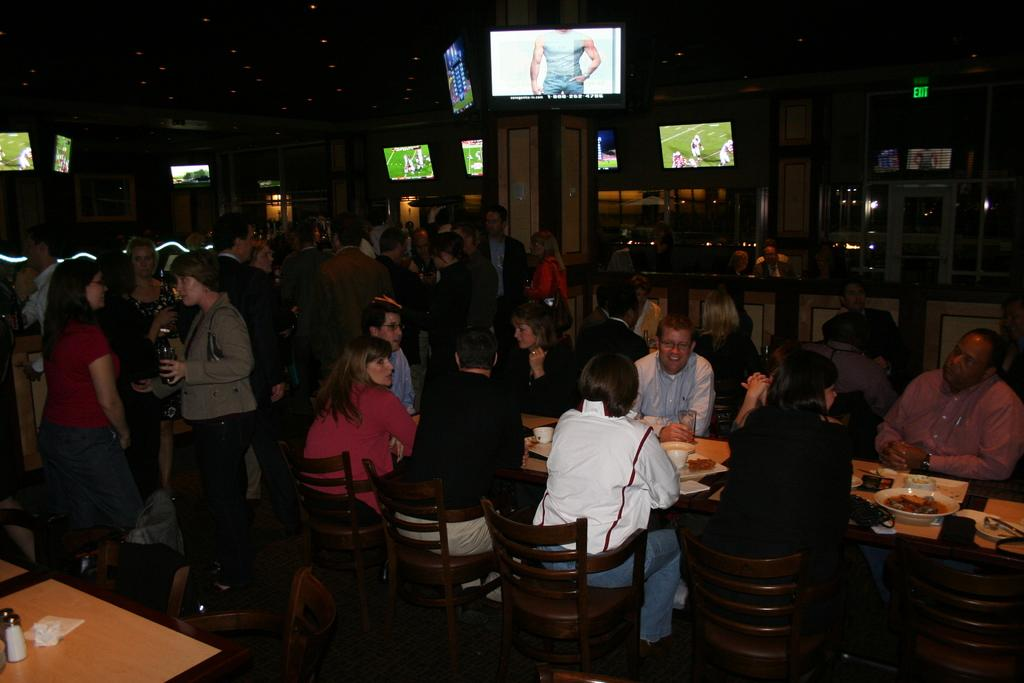How many people are in the image? There are people in the image, but the exact number is not specified. What are some of the people doing in the image? Some people are sitting on chairs, while others are standing. What type of furniture is present in the image? There are tables in the image. What can be seen in the background of the image? There are screens in the background. Can you see a rabbit hopping in the middle of the image? There is no rabbit present in the image. 